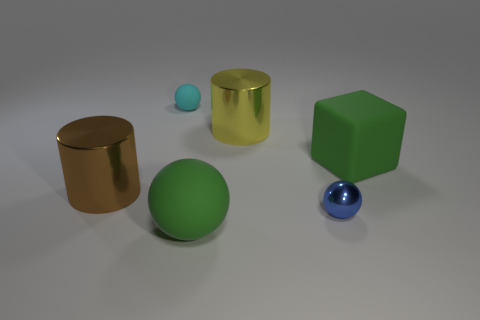Is there anything else that is the same size as the green cube?
Offer a very short reply. Yes. Is the number of small cyan rubber objects that are right of the blue metal object greater than the number of big metallic cylinders?
Offer a terse response. No. Is the shape of the small cyan thing the same as the large green matte thing behind the brown thing?
Your response must be concise. No. How many blue spheres are the same size as the green matte ball?
Your response must be concise. 0. How many yellow metallic objects are in front of the big green matte thing that is in front of the green matte object behind the tiny metallic ball?
Make the answer very short. 0. Are there an equal number of cyan rubber objects in front of the large rubber ball and blue objects behind the blue ball?
Your answer should be very brief. Yes. What number of other big shiny things are the same shape as the brown metallic thing?
Make the answer very short. 1. Is there a small cyan ball made of the same material as the brown object?
Keep it short and to the point. No. What shape is the big object that is the same color as the large ball?
Keep it short and to the point. Cube. How many blue metallic spheres are there?
Your answer should be very brief. 1. 